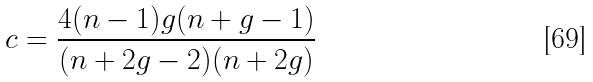Convert formula to latex. <formula><loc_0><loc_0><loc_500><loc_500>c = \frac { 4 ( n - 1 ) g ( n + g - 1 ) } { ( n + 2 g - 2 ) ( n + 2 g ) }</formula> 